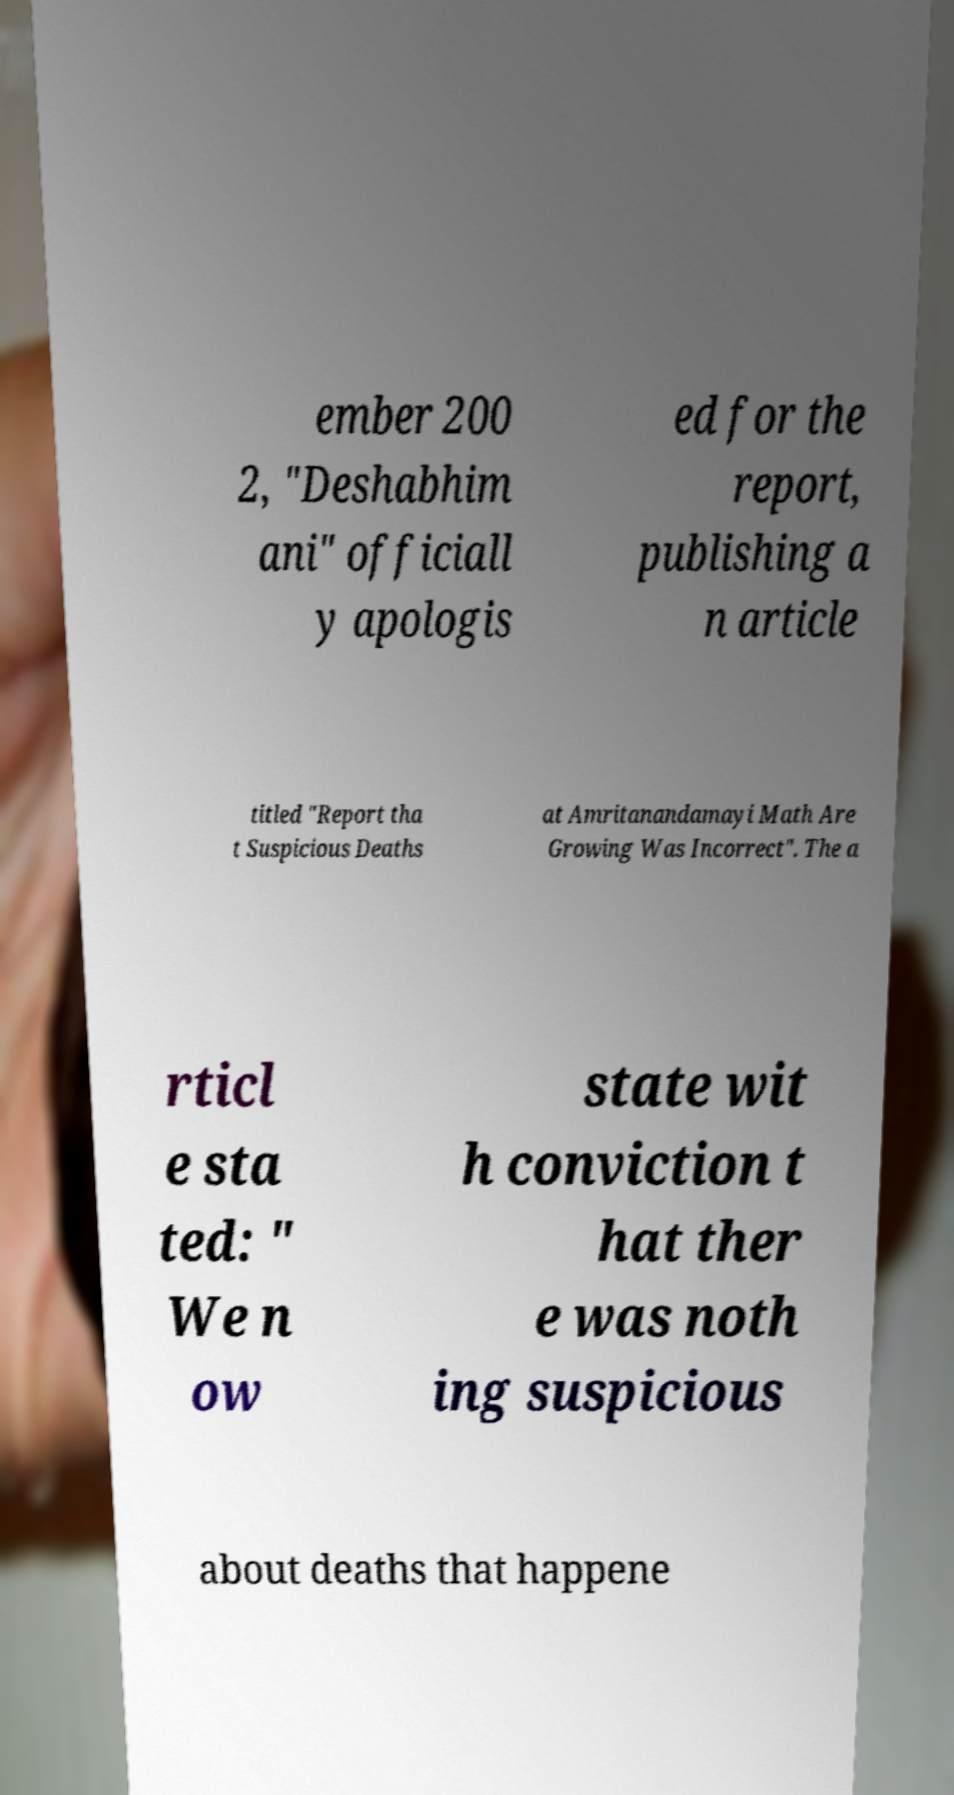Could you assist in decoding the text presented in this image and type it out clearly? ember 200 2, "Deshabhim ani" officiall y apologis ed for the report, publishing a n article titled "Report tha t Suspicious Deaths at Amritanandamayi Math Are Growing Was Incorrect". The a rticl e sta ted: " We n ow state wit h conviction t hat ther e was noth ing suspicious about deaths that happene 